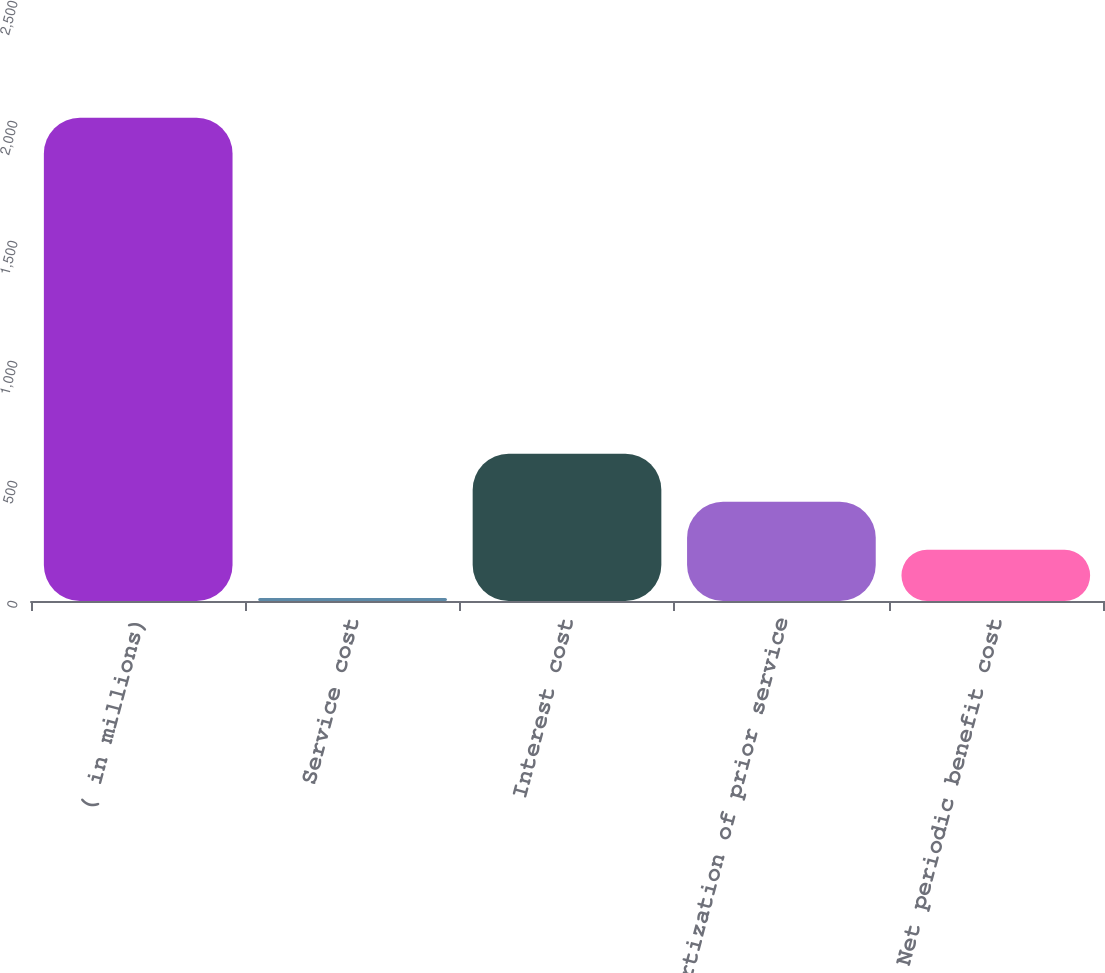Convert chart to OTSL. <chart><loc_0><loc_0><loc_500><loc_500><bar_chart><fcel>( in millions)<fcel>Service cost<fcel>Interest cost<fcel>Amortization of prior service<fcel>Net periodic benefit cost<nl><fcel>2014<fcel>13<fcel>613.3<fcel>413.2<fcel>213.1<nl></chart> 